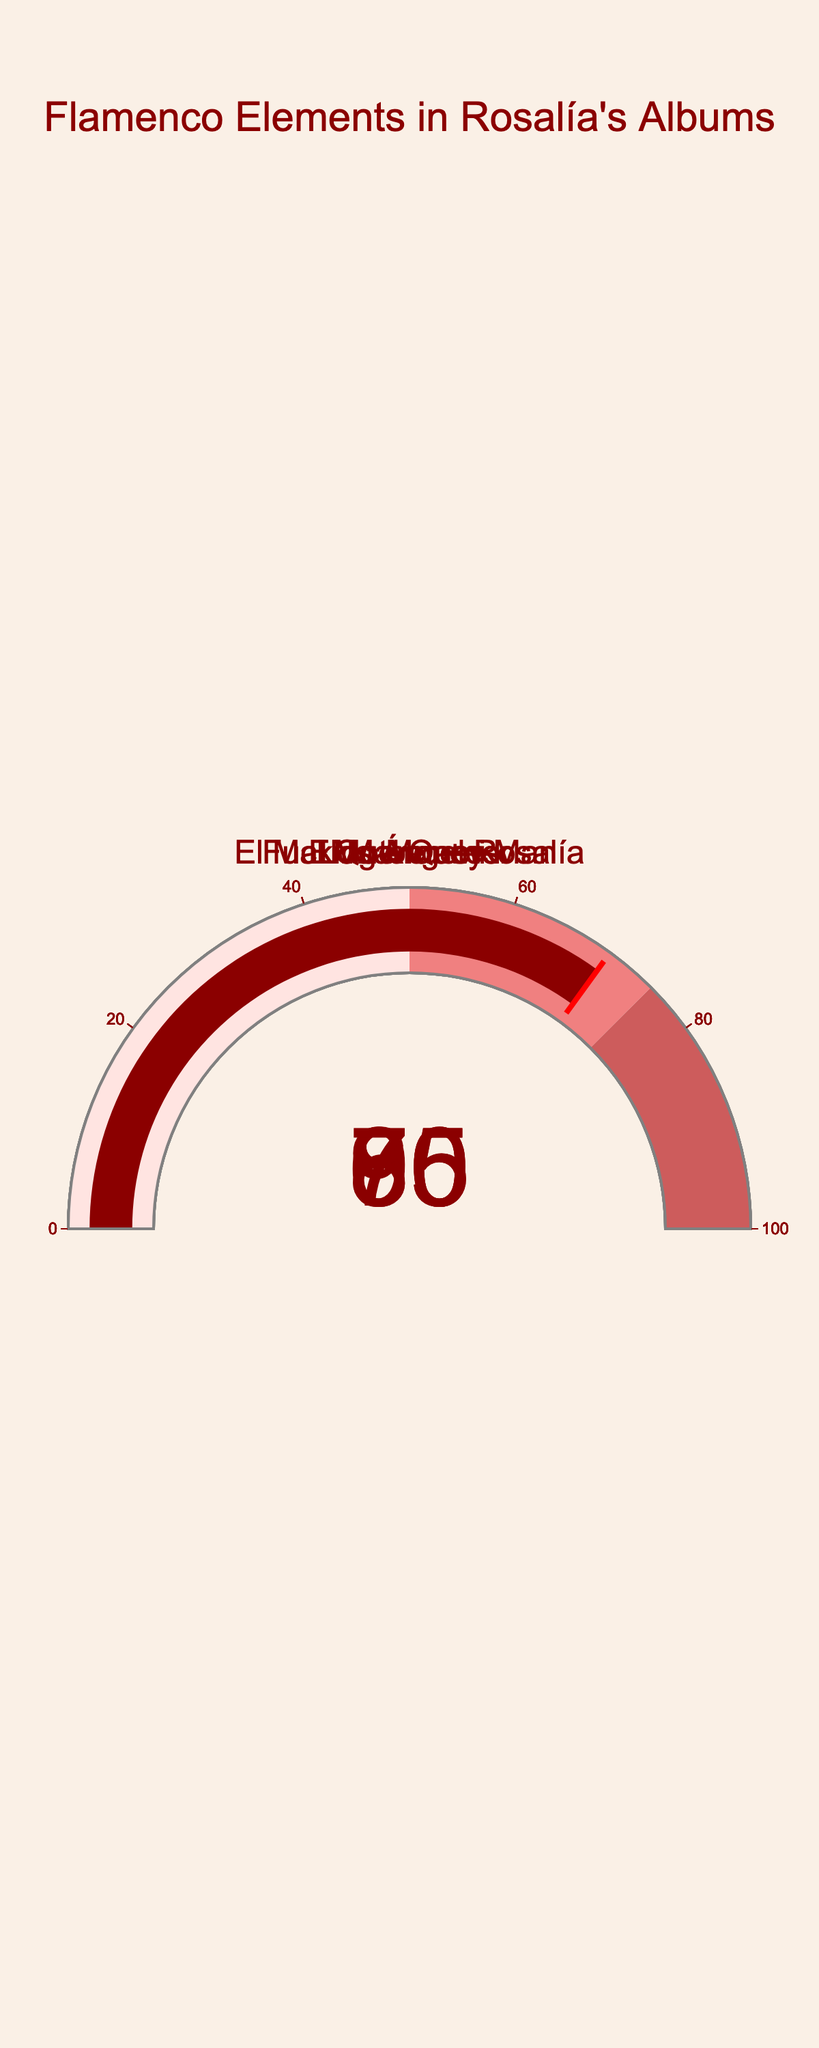What album has the highest percentage of flamenco elements? By looking at the gauge chart, the album with the highest number on the gauge will have the highest percentage of flamenco elements. "Los Ángeles" has the number 95, which is the highest.
Answer: Los Ángeles Which album has the lowest percentage of flamenco elements? The album with the lowest number on the gauge is the one with the lowest percentage. "Motomami" shows the number 60, which is the lowest.
Answer: Motomami What's the average flamenco percentage across all the albums? To calculate the average, sum up all the percentages and divide by the number of albums. (95 + 80 + 60 + 85 + 70) / 5 = 390 / 5 = 78
Answer: 78 How much more does "Los Ángeles" incorporate flamenco elements compared to "Motomami"? Subtracting the percentage value of "Motomami" from that of "Los Ángeles": 95 - 60 = 35
Answer: 35 Is the percentage of flamenco elements in "El Mal Querer" greater than in "Fucking Money Man"? Comparing the numbers on the gauges for these two albums, "El Mal Querer" shows 80 and "Fucking Money Man" shows 70. Since 80 > 70, the answer is yes.
Answer: Yes Rank the albums from highest to lowest percentage of flamenco elements. List the percentage values and order them. Los Ángeles (95), El Mal Querer + Rosalía (85), El Mal Querer (80), Fucking Money Man (70), Motomami (60)
Answer: Los Ángeles > El Mal Querer + Rosalía > El Mal Querer > Fucking Money Man > Motomami What is the combined flamenco percentage of "El Mal Querer" and "Fucking Money Man"? Addition of the two percentages: 80 + 70 = 150
Answer: 150 Does any album have equal to or above 90% of flamenco elements? Look at the percentage values on the gauges, "Los Ángeles" has 95 which is ≥ 90.
Answer: Yes Between "El Mal Querer" and "El Mal Querer + Rosalía", which has a higher flamenco percentage? Compare the percentage values, "El Mal Querer" (80) and "El Mal Querer + Rosalía" (85). 85 is higher than 80.
Answer: El Mal Querer + Rosalía What is the difference in flamenco percentage between the highest and lowest albums? Subtract the lowest value (Motomami: 60) from the highest value (Los Ángeles: 95). 95 - 60 = 35
Answer: 35 